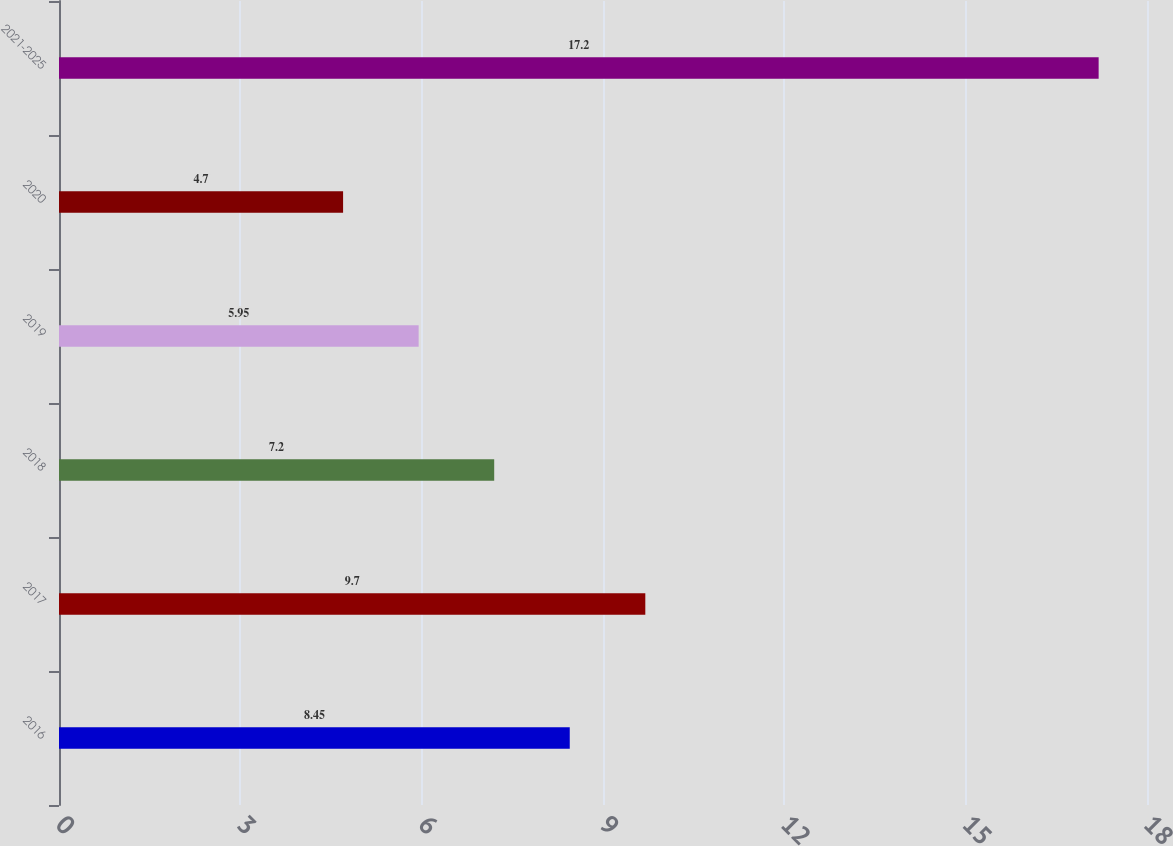<chart> <loc_0><loc_0><loc_500><loc_500><bar_chart><fcel>2016<fcel>2017<fcel>2018<fcel>2019<fcel>2020<fcel>2021-2025<nl><fcel>8.45<fcel>9.7<fcel>7.2<fcel>5.95<fcel>4.7<fcel>17.2<nl></chart> 